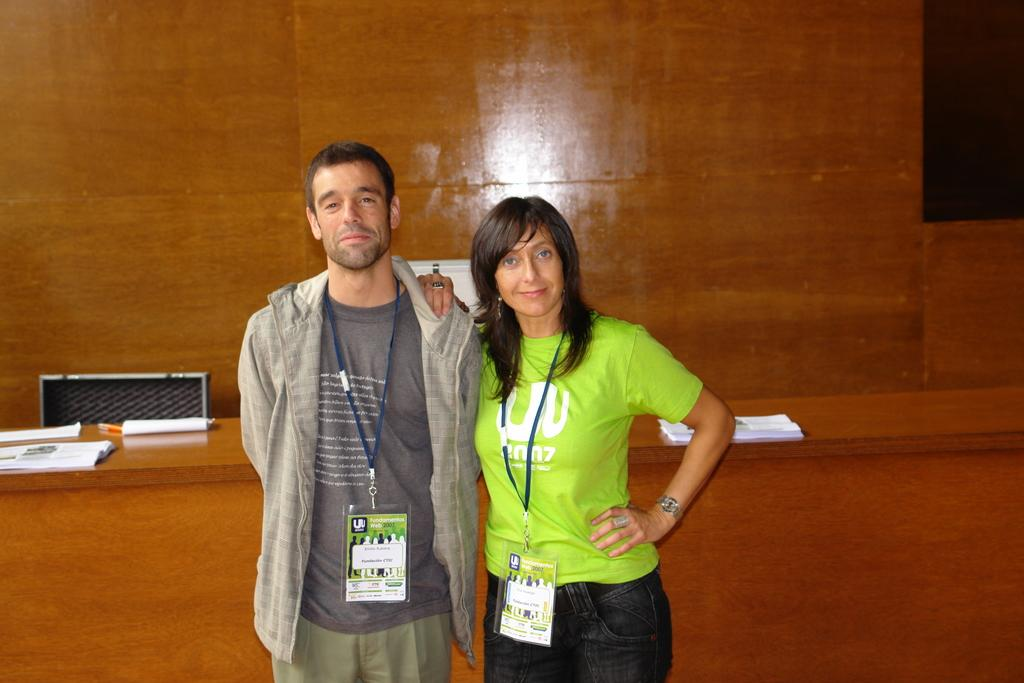How many people are in the image? There are two persons standing in the middle of the image. What are the persons doing in the image? The persons are smiling. What is located behind the persons? There is a table behind the persons. What items can be seen on the table? There are papers and pens on the table. What is visible at the top of the image? There is a wall visible at the top of the image. What type of destruction can be seen in the image? There is no destruction present in the image; it features two smiling persons, a table with papers and pens, and a wall visible at the top. Can you tell me how many farmers are in the image? There are no farmers present in the image. 